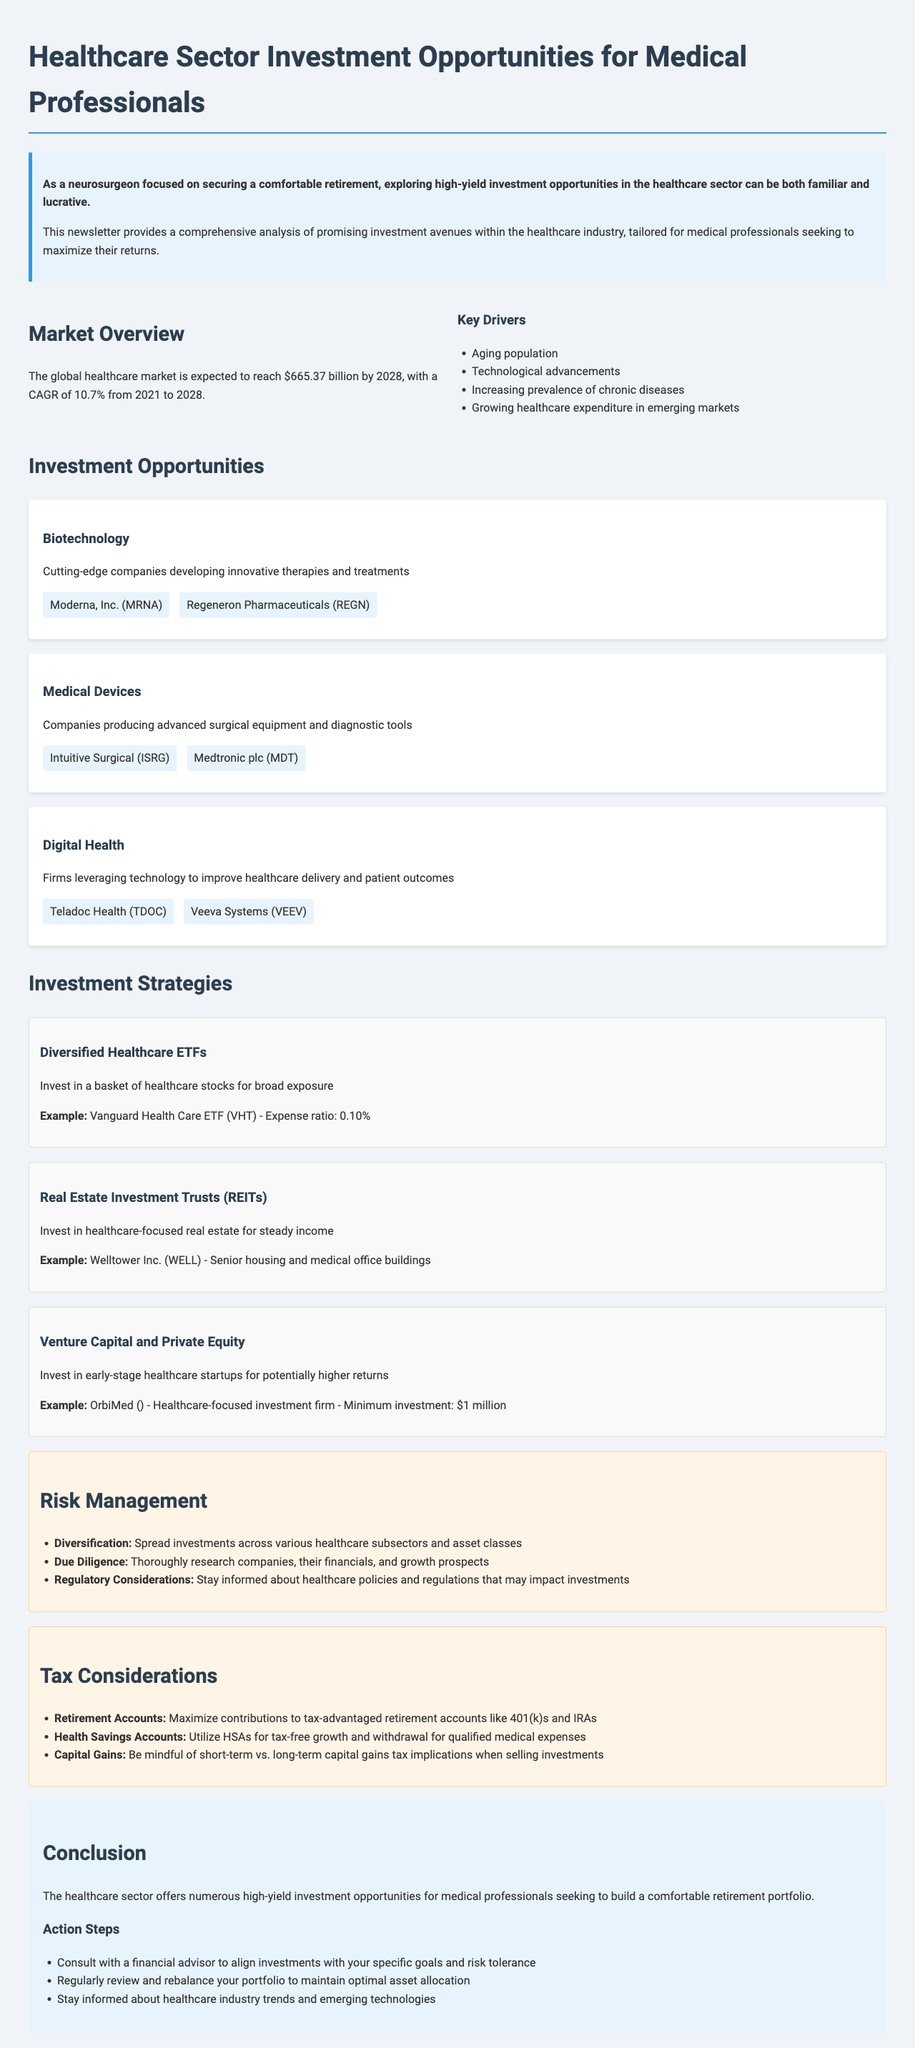What is the expected market size of the healthcare sector by 2028? The document states that the global healthcare market is expected to reach $665.37 billion by 2028.
Answer: $665.37 billion What is the CAGR of the healthcare market from 2021 to 2028? The document mentions a CAGR of 10.7% during that period.
Answer: 10.7% Which company focuses on mRNA therapeutics and vaccines? The newsletter provides an example of a biotechnology company that focuses on this area.
Answer: Moderna, Inc What is an example of a diversified healthcare ETF mentioned in the newsletter? The document lists the Vanguard Health Care ETF as a specific example.
Answer: Vanguard Health Care ETF What is a key driver of growth in the healthcare sector? The document lists factors contributing to market growth, such as an aging population.
Answer: Aging population What strategy involves investing in early-stage healthcare startups? The document specifically refers to a type of investment strategy characterized by this approach.
Answer: Venture Capital and Private Equity What should investors do for optimal risk management according to the newsletter? The document advises spreading investments across various healthcare subsectors and asset classes.
Answer: Diversification How much is the minimum investment for OrbiMed? OrbiMed is mentioned as requiring a certain amount to invest, which is specified in the document.
Answer: $1 million 